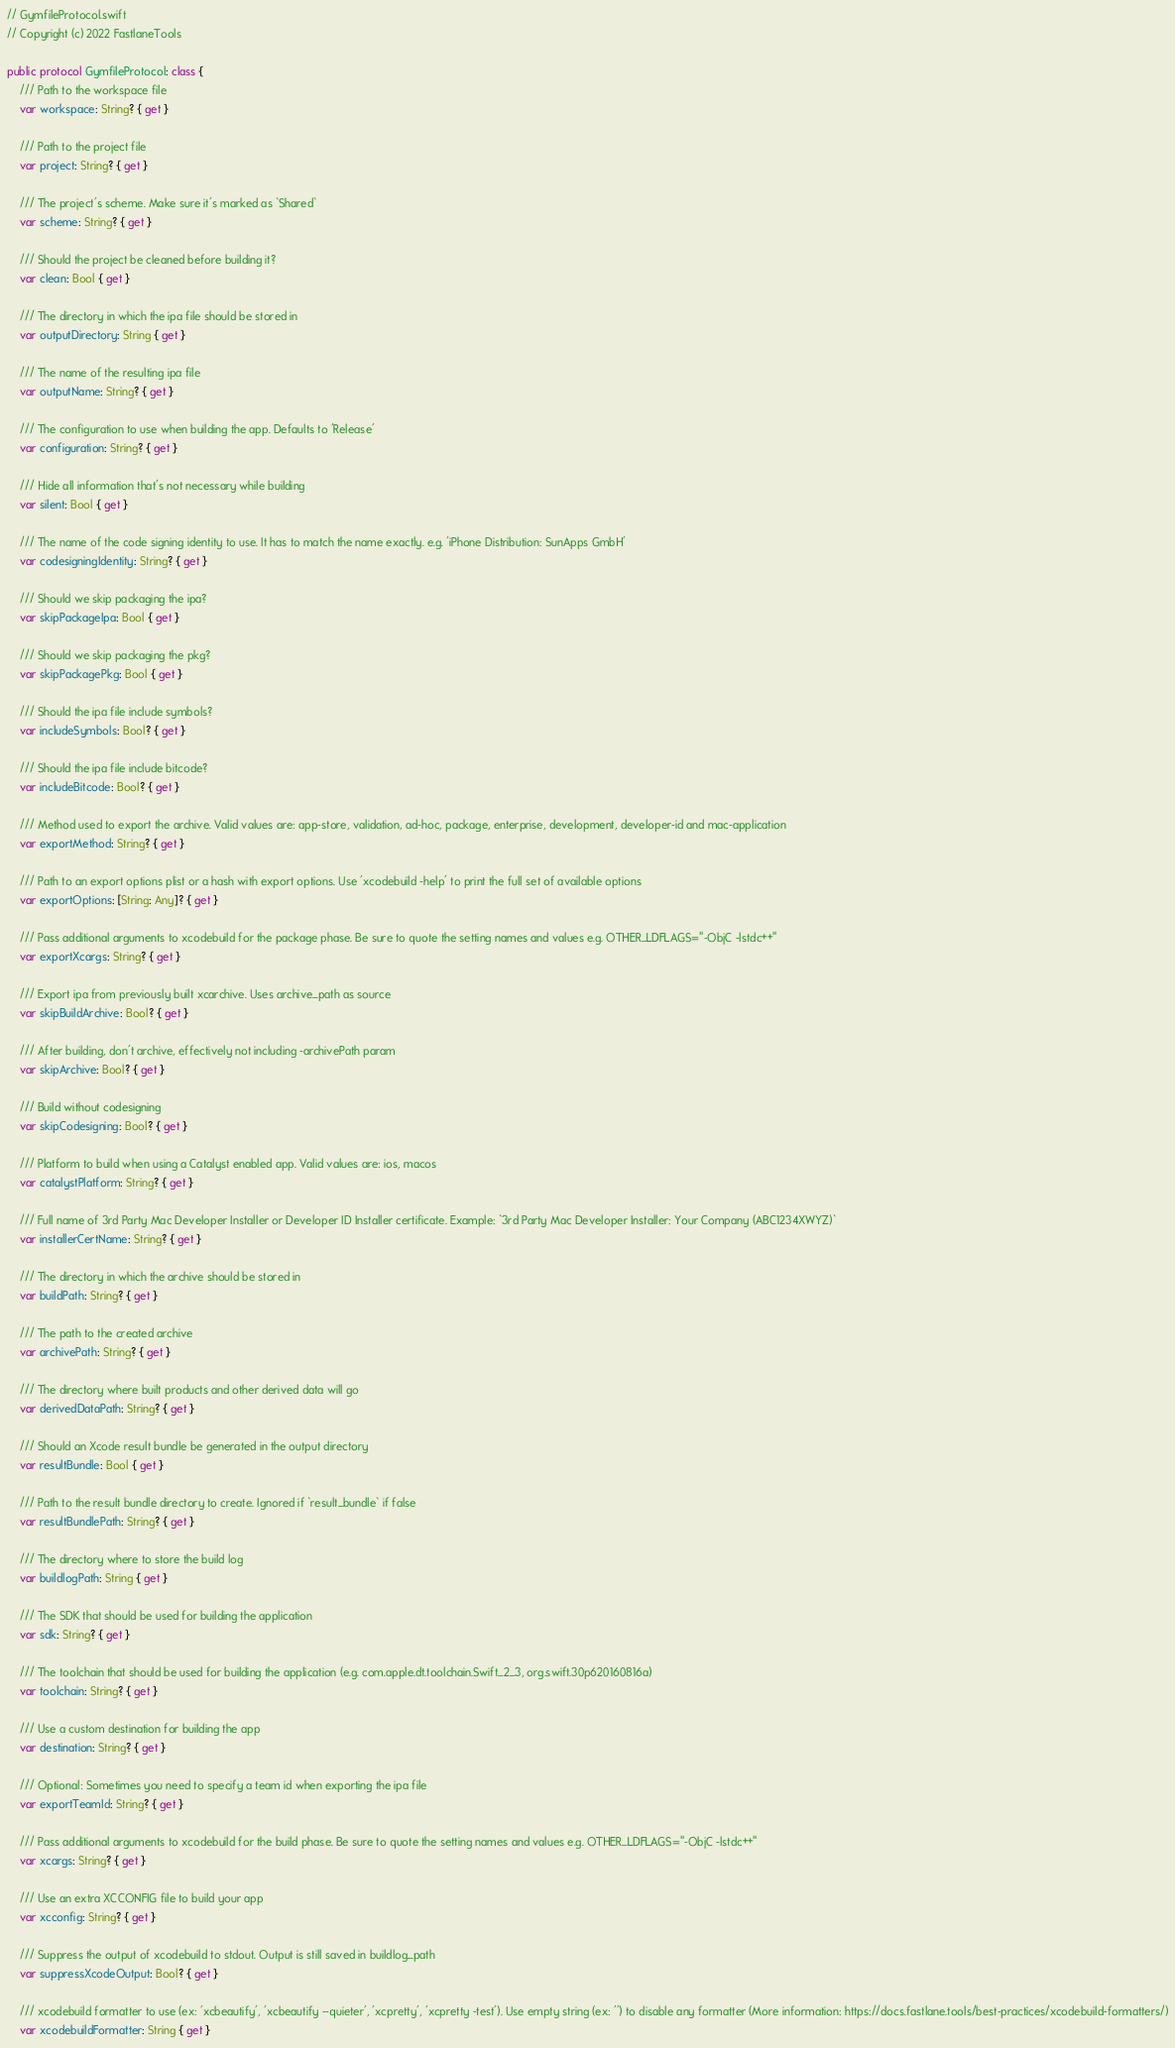<code> <loc_0><loc_0><loc_500><loc_500><_Swift_>// GymfileProtocol.swift
// Copyright (c) 2022 FastlaneTools

public protocol GymfileProtocol: class {
    /// Path to the workspace file
    var workspace: String? { get }

    /// Path to the project file
    var project: String? { get }

    /// The project's scheme. Make sure it's marked as `Shared`
    var scheme: String? { get }

    /// Should the project be cleaned before building it?
    var clean: Bool { get }

    /// The directory in which the ipa file should be stored in
    var outputDirectory: String { get }

    /// The name of the resulting ipa file
    var outputName: String? { get }

    /// The configuration to use when building the app. Defaults to 'Release'
    var configuration: String? { get }

    /// Hide all information that's not necessary while building
    var silent: Bool { get }

    /// The name of the code signing identity to use. It has to match the name exactly. e.g. 'iPhone Distribution: SunApps GmbH'
    var codesigningIdentity: String? { get }

    /// Should we skip packaging the ipa?
    var skipPackageIpa: Bool { get }

    /// Should we skip packaging the pkg?
    var skipPackagePkg: Bool { get }

    /// Should the ipa file include symbols?
    var includeSymbols: Bool? { get }

    /// Should the ipa file include bitcode?
    var includeBitcode: Bool? { get }

    /// Method used to export the archive. Valid values are: app-store, validation, ad-hoc, package, enterprise, development, developer-id and mac-application
    var exportMethod: String? { get }

    /// Path to an export options plist or a hash with export options. Use 'xcodebuild -help' to print the full set of available options
    var exportOptions: [String: Any]? { get }

    /// Pass additional arguments to xcodebuild for the package phase. Be sure to quote the setting names and values e.g. OTHER_LDFLAGS="-ObjC -lstdc++"
    var exportXcargs: String? { get }

    /// Export ipa from previously built xcarchive. Uses archive_path as source
    var skipBuildArchive: Bool? { get }

    /// After building, don't archive, effectively not including -archivePath param
    var skipArchive: Bool? { get }

    /// Build without codesigning
    var skipCodesigning: Bool? { get }

    /// Platform to build when using a Catalyst enabled app. Valid values are: ios, macos
    var catalystPlatform: String? { get }

    /// Full name of 3rd Party Mac Developer Installer or Developer ID Installer certificate. Example: `3rd Party Mac Developer Installer: Your Company (ABC1234XWYZ)`
    var installerCertName: String? { get }

    /// The directory in which the archive should be stored in
    var buildPath: String? { get }

    /// The path to the created archive
    var archivePath: String? { get }

    /// The directory where built products and other derived data will go
    var derivedDataPath: String? { get }

    /// Should an Xcode result bundle be generated in the output directory
    var resultBundle: Bool { get }

    /// Path to the result bundle directory to create. Ignored if `result_bundle` if false
    var resultBundlePath: String? { get }

    /// The directory where to store the build log
    var buildlogPath: String { get }

    /// The SDK that should be used for building the application
    var sdk: String? { get }

    /// The toolchain that should be used for building the application (e.g. com.apple.dt.toolchain.Swift_2_3, org.swift.30p620160816a)
    var toolchain: String? { get }

    /// Use a custom destination for building the app
    var destination: String? { get }

    /// Optional: Sometimes you need to specify a team id when exporting the ipa file
    var exportTeamId: String? { get }

    /// Pass additional arguments to xcodebuild for the build phase. Be sure to quote the setting names and values e.g. OTHER_LDFLAGS="-ObjC -lstdc++"
    var xcargs: String? { get }

    /// Use an extra XCCONFIG file to build your app
    var xcconfig: String? { get }

    /// Suppress the output of xcodebuild to stdout. Output is still saved in buildlog_path
    var suppressXcodeOutput: Bool? { get }

    /// xcodebuild formatter to use (ex: 'xcbeautify', 'xcbeautify --quieter', 'xcpretty', 'xcpretty -test'). Use empty string (ex: '') to disable any formatter (More information: https://docs.fastlane.tools/best-practices/xcodebuild-formatters/)
    var xcodebuildFormatter: String { get }
</code> 